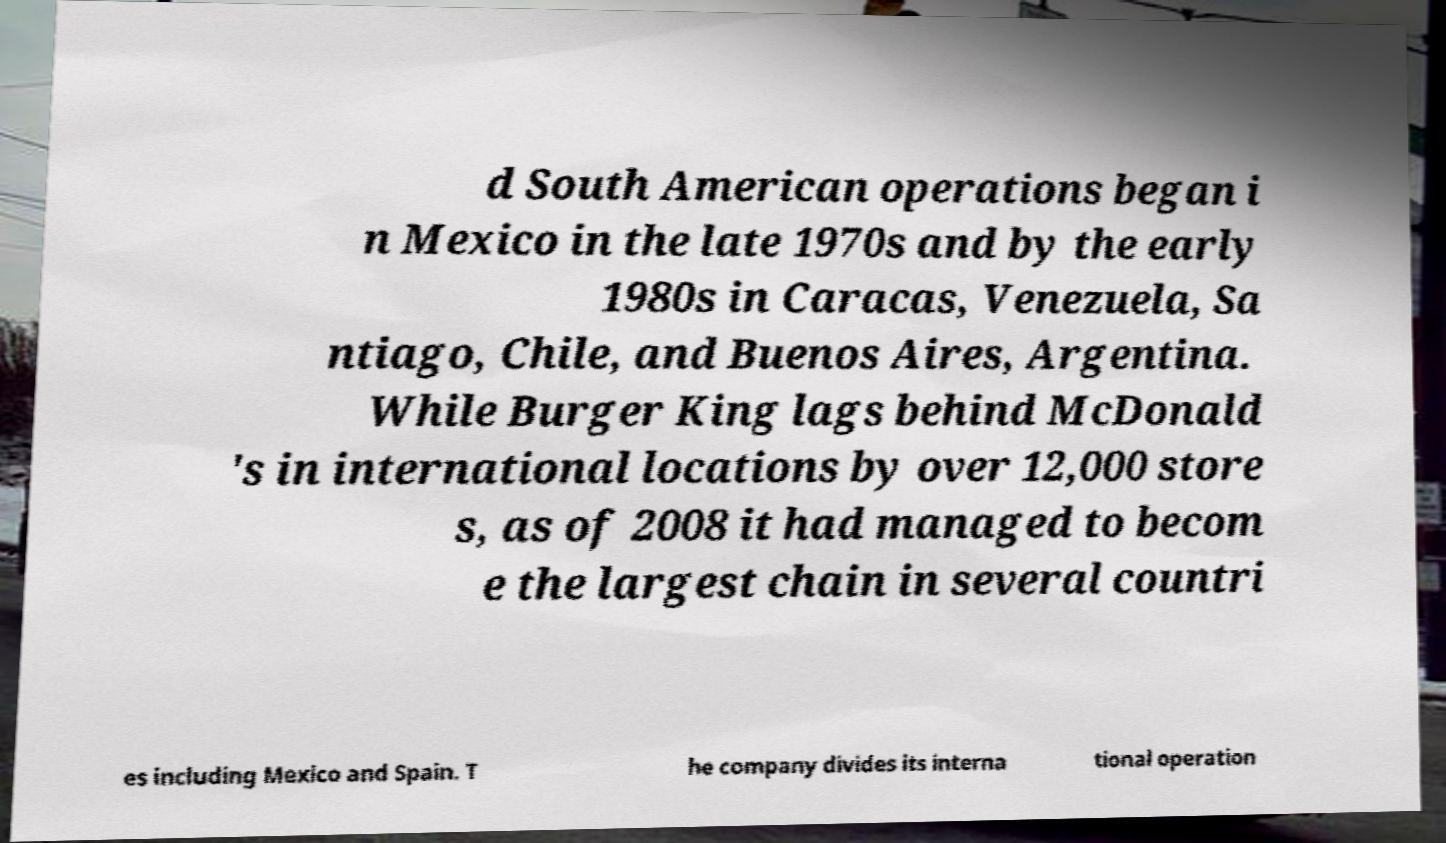For documentation purposes, I need the text within this image transcribed. Could you provide that? d South American operations began i n Mexico in the late 1970s and by the early 1980s in Caracas, Venezuela, Sa ntiago, Chile, and Buenos Aires, Argentina. While Burger King lags behind McDonald 's in international locations by over 12,000 store s, as of 2008 it had managed to becom e the largest chain in several countri es including Mexico and Spain. T he company divides its interna tional operation 